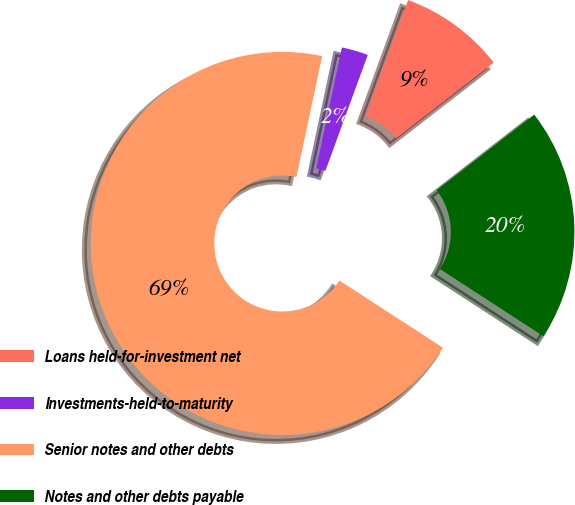Convert chart to OTSL. <chart><loc_0><loc_0><loc_500><loc_500><pie_chart><fcel>Loans held-for-investment net<fcel>Investments-held-to-maturity<fcel>Senior notes and other debts<fcel>Notes and other debts payable<nl><fcel>8.93%<fcel>2.24%<fcel>69.18%<fcel>19.66%<nl></chart> 